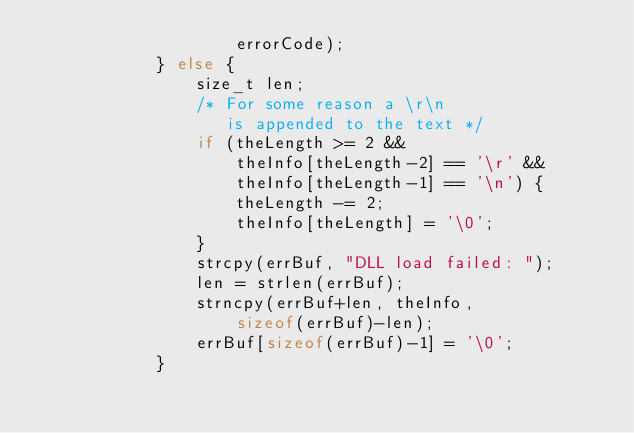<code> <loc_0><loc_0><loc_500><loc_500><_C_>					errorCode);
			} else {
				size_t len;
				/* For some reason a \r\n
				   is appended to the text */
				if (theLength >= 2 &&
				    theInfo[theLength-2] == '\r' &&
				    theInfo[theLength-1] == '\n') {
					theLength -= 2;
					theInfo[theLength] = '\0';
				}
				strcpy(errBuf, "DLL load failed: ");
				len = strlen(errBuf);
				strncpy(errBuf+len, theInfo,
					sizeof(errBuf)-len);
				errBuf[sizeof(errBuf)-1] = '\0';
			}</code> 